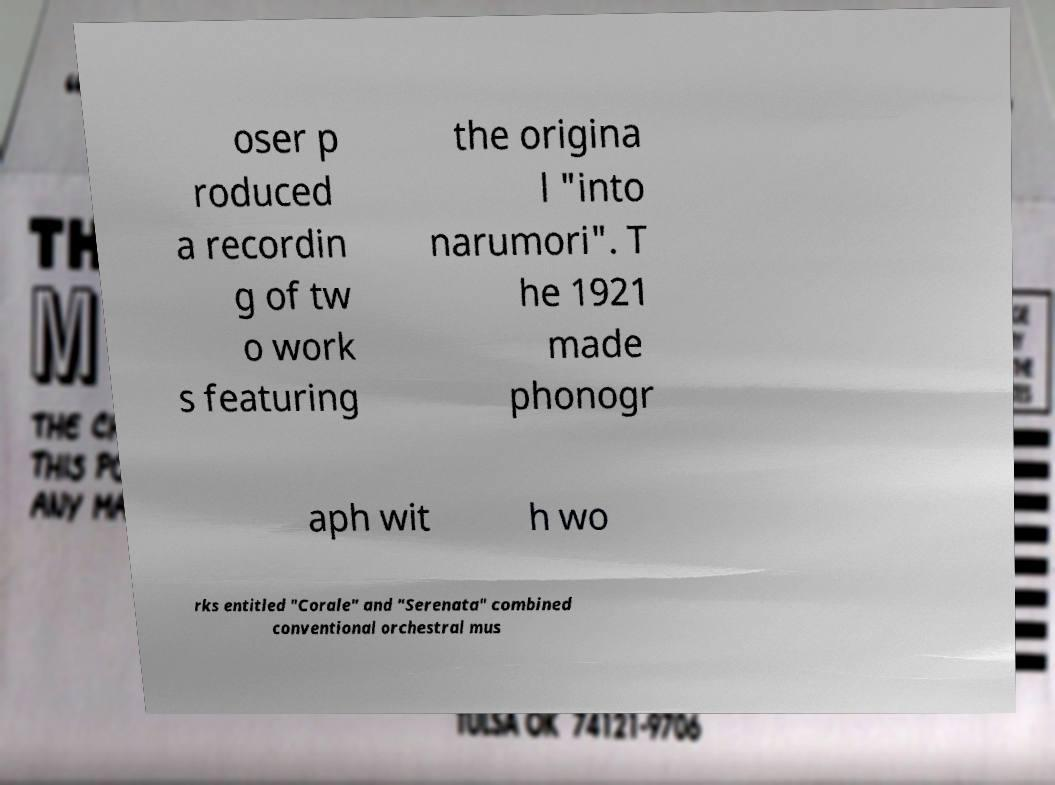What messages or text are displayed in this image? I need them in a readable, typed format. oser p roduced a recordin g of tw o work s featuring the origina l "into narumori". T he 1921 made phonogr aph wit h wo rks entitled "Corale" and "Serenata" combined conventional orchestral mus 